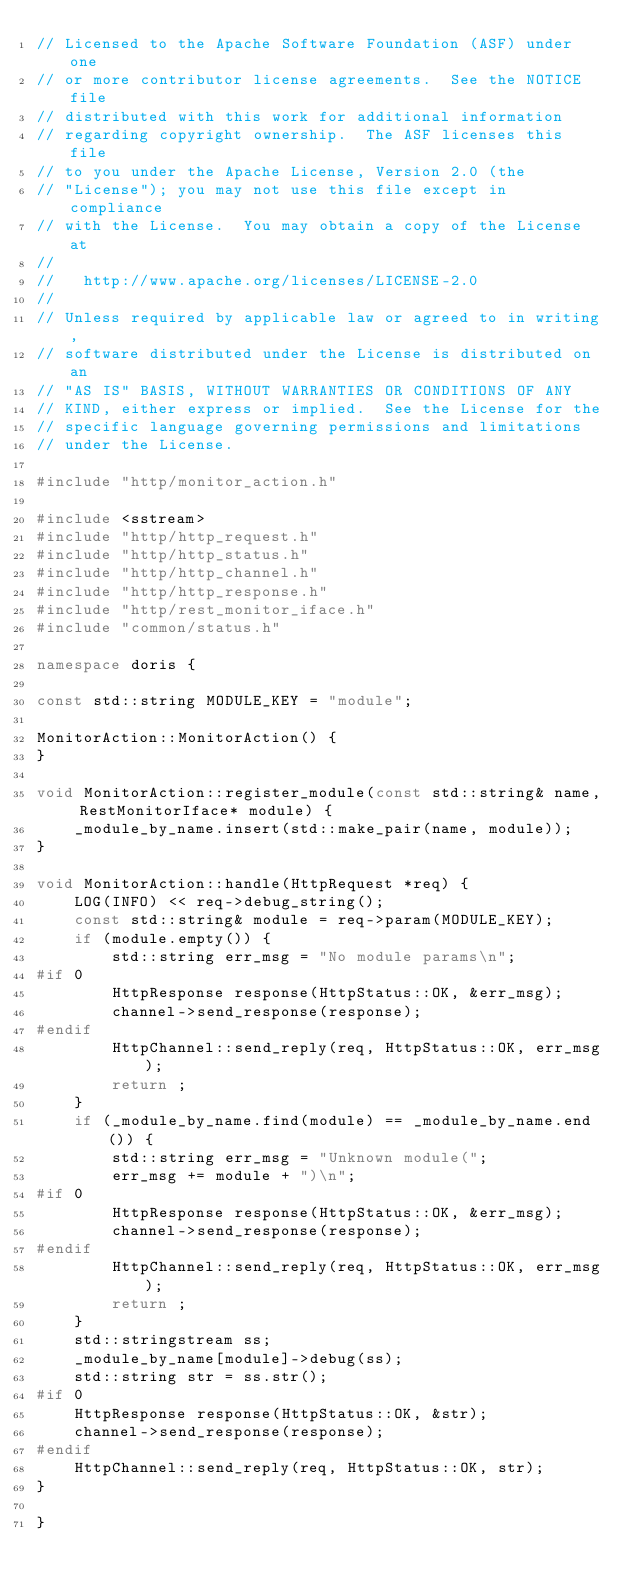<code> <loc_0><loc_0><loc_500><loc_500><_C++_>// Licensed to the Apache Software Foundation (ASF) under one
// or more contributor license agreements.  See the NOTICE file
// distributed with this work for additional information
// regarding copyright ownership.  The ASF licenses this file
// to you under the Apache License, Version 2.0 (the
// "License"); you may not use this file except in compliance
// with the License.  You may obtain a copy of the License at
//
//   http://www.apache.org/licenses/LICENSE-2.0
//
// Unless required by applicable law or agreed to in writing,
// software distributed under the License is distributed on an
// "AS IS" BASIS, WITHOUT WARRANTIES OR CONDITIONS OF ANY
// KIND, either express or implied.  See the License for the
// specific language governing permissions and limitations
// under the License.

#include "http/monitor_action.h"

#include <sstream>
#include "http/http_request.h"
#include "http/http_status.h"
#include "http/http_channel.h"
#include "http/http_response.h"
#include "http/rest_monitor_iface.h"
#include "common/status.h"

namespace doris {

const std::string MODULE_KEY = "module";

MonitorAction::MonitorAction() {
}

void MonitorAction::register_module(const std::string& name, RestMonitorIface* module) {
    _module_by_name.insert(std::make_pair(name, module));
}

void MonitorAction::handle(HttpRequest *req) {
    LOG(INFO) << req->debug_string();
    const std::string& module = req->param(MODULE_KEY);
    if (module.empty()) {
        std::string err_msg = "No module params\n";
#if 0
        HttpResponse response(HttpStatus::OK, &err_msg);
        channel->send_response(response);
#endif
        HttpChannel::send_reply(req, HttpStatus::OK, err_msg);
        return ;
    }
    if (_module_by_name.find(module) == _module_by_name.end()) {
        std::string err_msg = "Unknown module(";
        err_msg += module + ")\n";
#if 0
        HttpResponse response(HttpStatus::OK, &err_msg);
        channel->send_response(response);
#endif
        HttpChannel::send_reply(req, HttpStatus::OK, err_msg);
        return ;
    }
    std::stringstream ss;
    _module_by_name[module]->debug(ss);
    std::string str = ss.str();
#if 0
    HttpResponse response(HttpStatus::OK, &str);
    channel->send_response(response);
#endif
    HttpChannel::send_reply(req, HttpStatus::OK, str);
}

}

</code> 